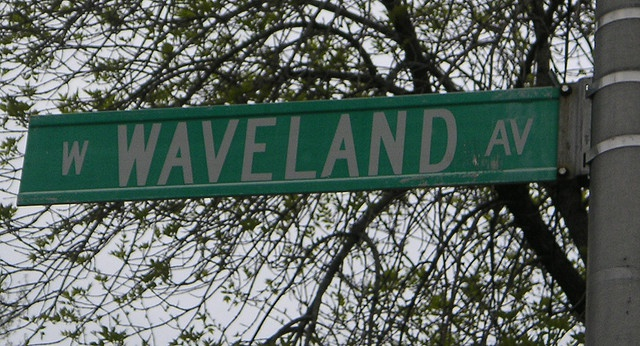Describe the objects in this image and their specific colors. I can see various objects in this image with different colors. 